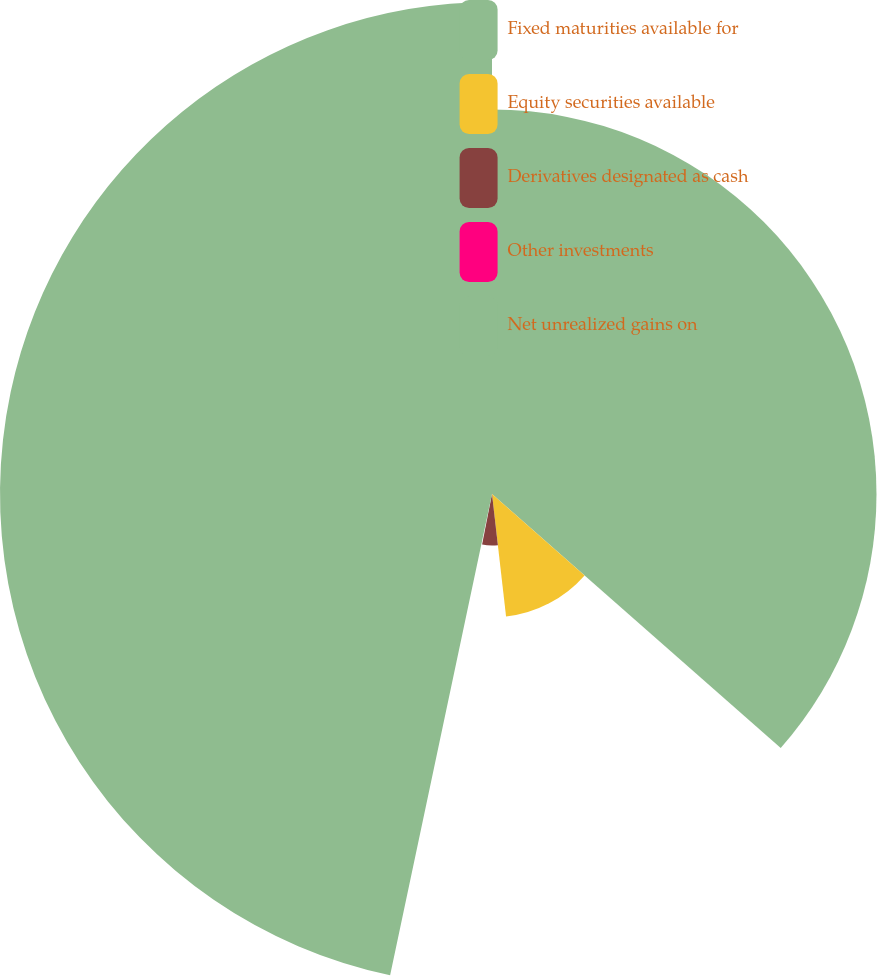Convert chart. <chart><loc_0><loc_0><loc_500><loc_500><pie_chart><fcel>Fixed maturities available for<fcel>Equity securities available<fcel>Derivatives designated as cash<fcel>Other investments<fcel>Net unrealized gains on<nl><fcel>36.48%<fcel>11.7%<fcel>4.89%<fcel>0.25%<fcel>46.68%<nl></chart> 